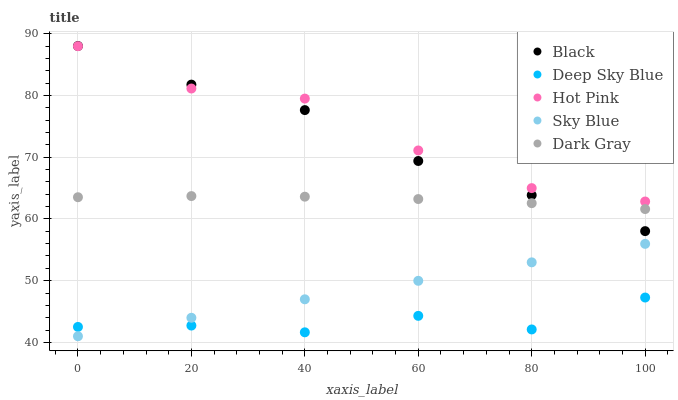Does Deep Sky Blue have the minimum area under the curve?
Answer yes or no. Yes. Does Hot Pink have the maximum area under the curve?
Answer yes or no. Yes. Does Sky Blue have the minimum area under the curve?
Answer yes or no. No. Does Sky Blue have the maximum area under the curve?
Answer yes or no. No. Is Sky Blue the smoothest?
Answer yes or no. Yes. Is Hot Pink the roughest?
Answer yes or no. Yes. Is Hot Pink the smoothest?
Answer yes or no. No. Is Sky Blue the roughest?
Answer yes or no. No. Does Sky Blue have the lowest value?
Answer yes or no. Yes. Does Hot Pink have the lowest value?
Answer yes or no. No. Does Black have the highest value?
Answer yes or no. Yes. Does Sky Blue have the highest value?
Answer yes or no. No. Is Deep Sky Blue less than Hot Pink?
Answer yes or no. Yes. Is Hot Pink greater than Sky Blue?
Answer yes or no. Yes. Does Sky Blue intersect Deep Sky Blue?
Answer yes or no. Yes. Is Sky Blue less than Deep Sky Blue?
Answer yes or no. No. Is Sky Blue greater than Deep Sky Blue?
Answer yes or no. No. Does Deep Sky Blue intersect Hot Pink?
Answer yes or no. No. 